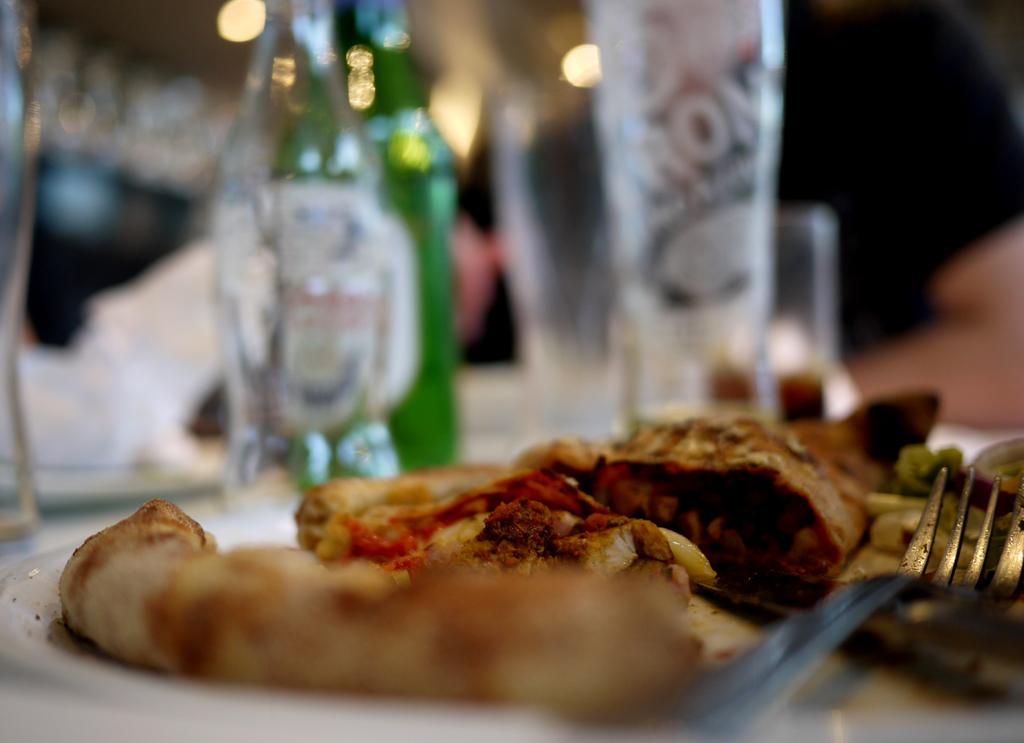Please provide a concise description of this image. In the foreground, I can see liquor bottles and food items on a table. The background is not clear. This picture might be taken in a hotel. 